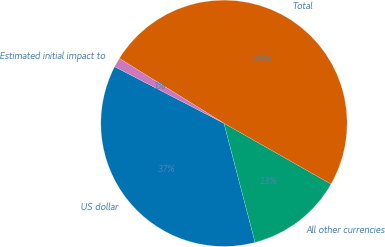<chart> <loc_0><loc_0><loc_500><loc_500><pie_chart><fcel>US dollar<fcel>All other currencies<fcel>Total<fcel>Estimated initial impact to<nl><fcel>36.67%<fcel>12.72%<fcel>49.39%<fcel>1.23%<nl></chart> 